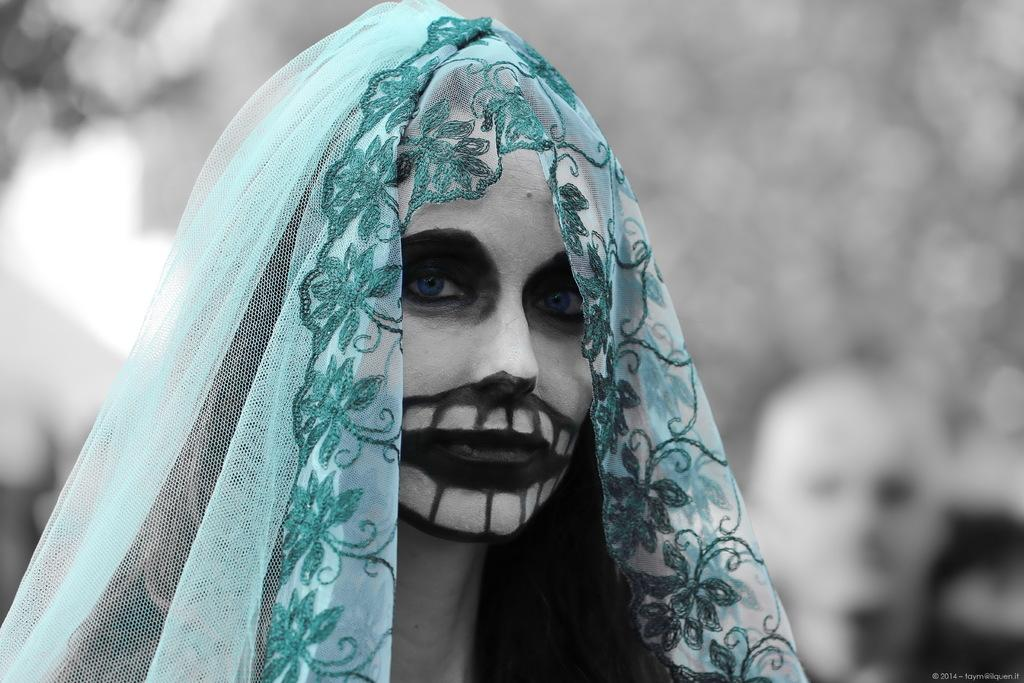What is the main subject of the image? There is a person in the image. What can be observed about the person's appearance? The person is wearing Halloween makeup and a mesh cloth. How would you describe the background of the image? The background of the image is blurred. What type of celery is being used as a watch accessory in the image? There is no celery or watch present in the image; the person is wearing Halloween makeup and a mesh cloth. 